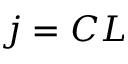<formula> <loc_0><loc_0><loc_500><loc_500>j = C L</formula> 